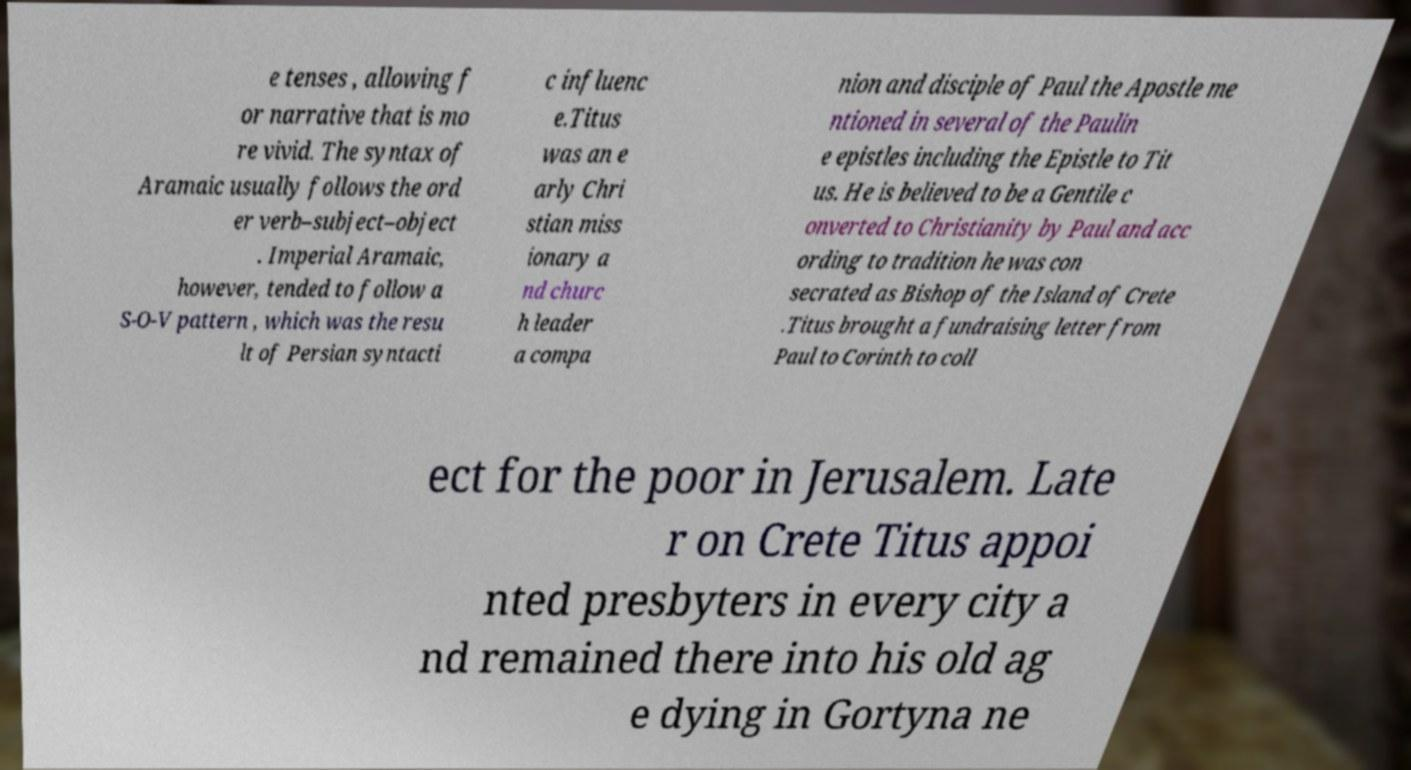Can you read and provide the text displayed in the image?This photo seems to have some interesting text. Can you extract and type it out for me? e tenses , allowing f or narrative that is mo re vivid. The syntax of Aramaic usually follows the ord er verb–subject–object . Imperial Aramaic, however, tended to follow a S-O-V pattern , which was the resu lt of Persian syntacti c influenc e.Titus was an e arly Chri stian miss ionary a nd churc h leader a compa nion and disciple of Paul the Apostle me ntioned in several of the Paulin e epistles including the Epistle to Tit us. He is believed to be a Gentile c onverted to Christianity by Paul and acc ording to tradition he was con secrated as Bishop of the Island of Crete .Titus brought a fundraising letter from Paul to Corinth to coll ect for the poor in Jerusalem. Late r on Crete Titus appoi nted presbyters in every city a nd remained there into his old ag e dying in Gortyna ne 